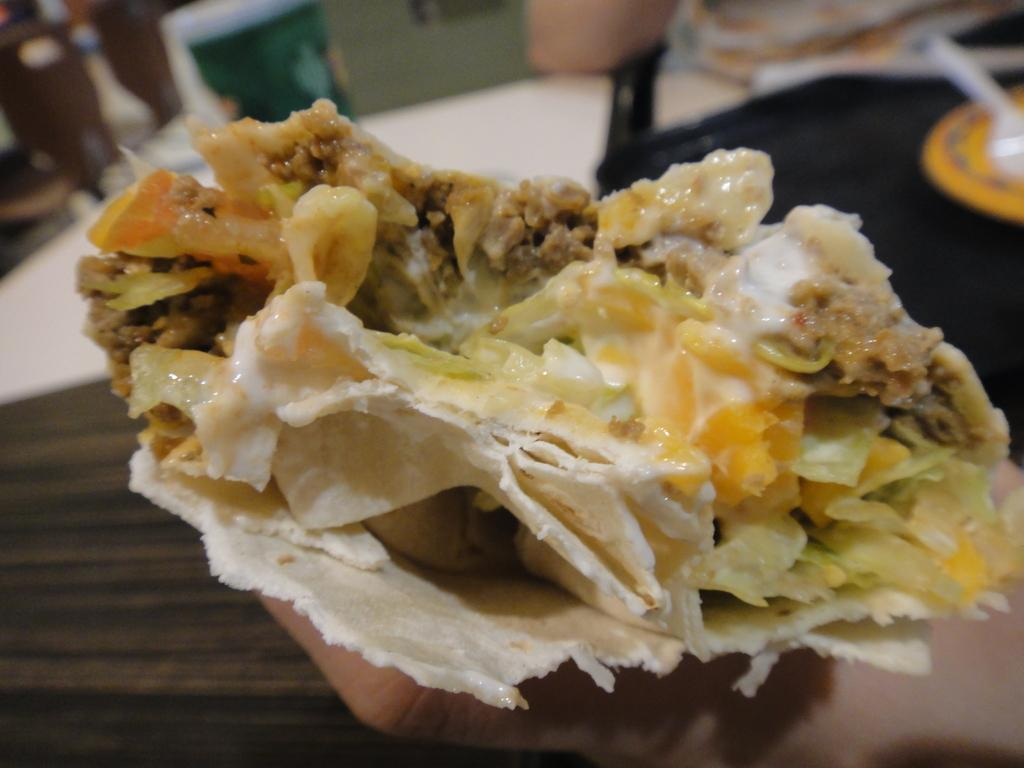What is the main subject of the image? The main subject of the image is a human hand. What is the hand doing in the image? The hand is holding food. What type of tub can be seen in the image? There is no tub present in the image; it features a human hand holding food. How does the hand's position affect the acoustics in the image? The hand's position does not affect the acoustics in the image, as there is no mention of sound or acoustics in the provided facts. 